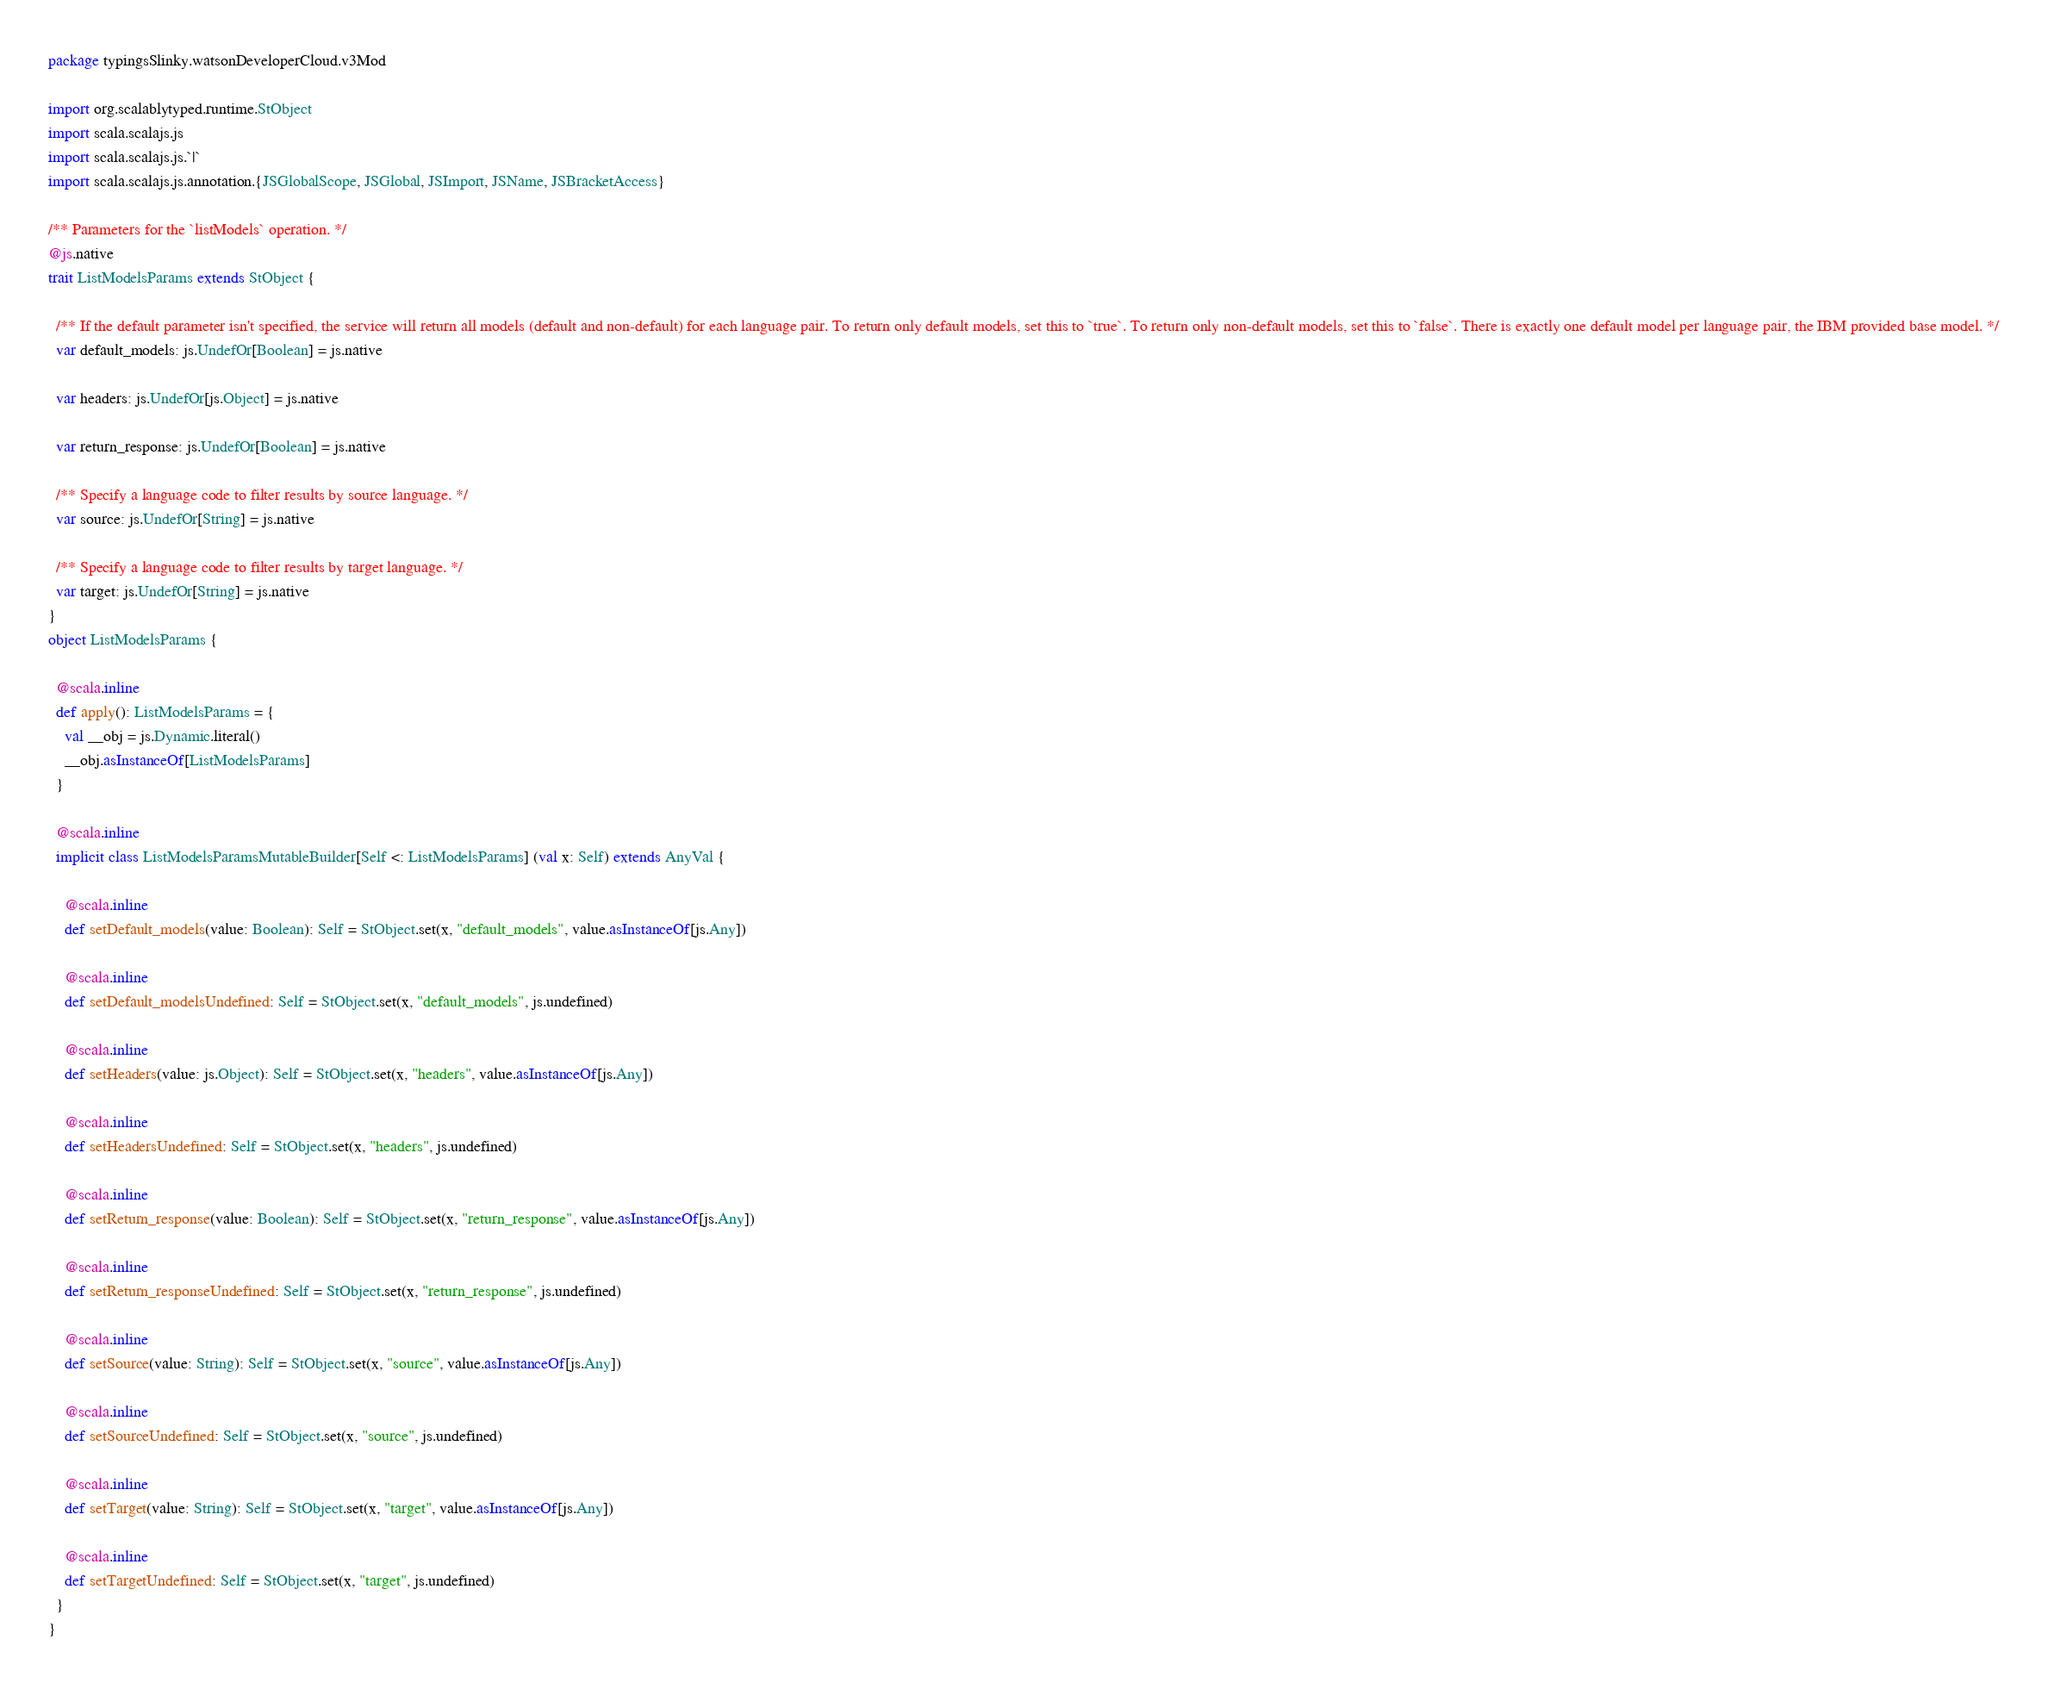Convert code to text. <code><loc_0><loc_0><loc_500><loc_500><_Scala_>package typingsSlinky.watsonDeveloperCloud.v3Mod

import org.scalablytyped.runtime.StObject
import scala.scalajs.js
import scala.scalajs.js.`|`
import scala.scalajs.js.annotation.{JSGlobalScope, JSGlobal, JSImport, JSName, JSBracketAccess}

/** Parameters for the `listModels` operation. */
@js.native
trait ListModelsParams extends StObject {
  
  /** If the default parameter isn't specified, the service will return all models (default and non-default) for each language pair. To return only default models, set this to `true`. To return only non-default models, set this to `false`. There is exactly one default model per language pair, the IBM provided base model. */
  var default_models: js.UndefOr[Boolean] = js.native
  
  var headers: js.UndefOr[js.Object] = js.native
  
  var return_response: js.UndefOr[Boolean] = js.native
  
  /** Specify a language code to filter results by source language. */
  var source: js.UndefOr[String] = js.native
  
  /** Specify a language code to filter results by target language. */
  var target: js.UndefOr[String] = js.native
}
object ListModelsParams {
  
  @scala.inline
  def apply(): ListModelsParams = {
    val __obj = js.Dynamic.literal()
    __obj.asInstanceOf[ListModelsParams]
  }
  
  @scala.inline
  implicit class ListModelsParamsMutableBuilder[Self <: ListModelsParams] (val x: Self) extends AnyVal {
    
    @scala.inline
    def setDefault_models(value: Boolean): Self = StObject.set(x, "default_models", value.asInstanceOf[js.Any])
    
    @scala.inline
    def setDefault_modelsUndefined: Self = StObject.set(x, "default_models", js.undefined)
    
    @scala.inline
    def setHeaders(value: js.Object): Self = StObject.set(x, "headers", value.asInstanceOf[js.Any])
    
    @scala.inline
    def setHeadersUndefined: Self = StObject.set(x, "headers", js.undefined)
    
    @scala.inline
    def setReturn_response(value: Boolean): Self = StObject.set(x, "return_response", value.asInstanceOf[js.Any])
    
    @scala.inline
    def setReturn_responseUndefined: Self = StObject.set(x, "return_response", js.undefined)
    
    @scala.inline
    def setSource(value: String): Self = StObject.set(x, "source", value.asInstanceOf[js.Any])
    
    @scala.inline
    def setSourceUndefined: Self = StObject.set(x, "source", js.undefined)
    
    @scala.inline
    def setTarget(value: String): Self = StObject.set(x, "target", value.asInstanceOf[js.Any])
    
    @scala.inline
    def setTargetUndefined: Self = StObject.set(x, "target", js.undefined)
  }
}
</code> 